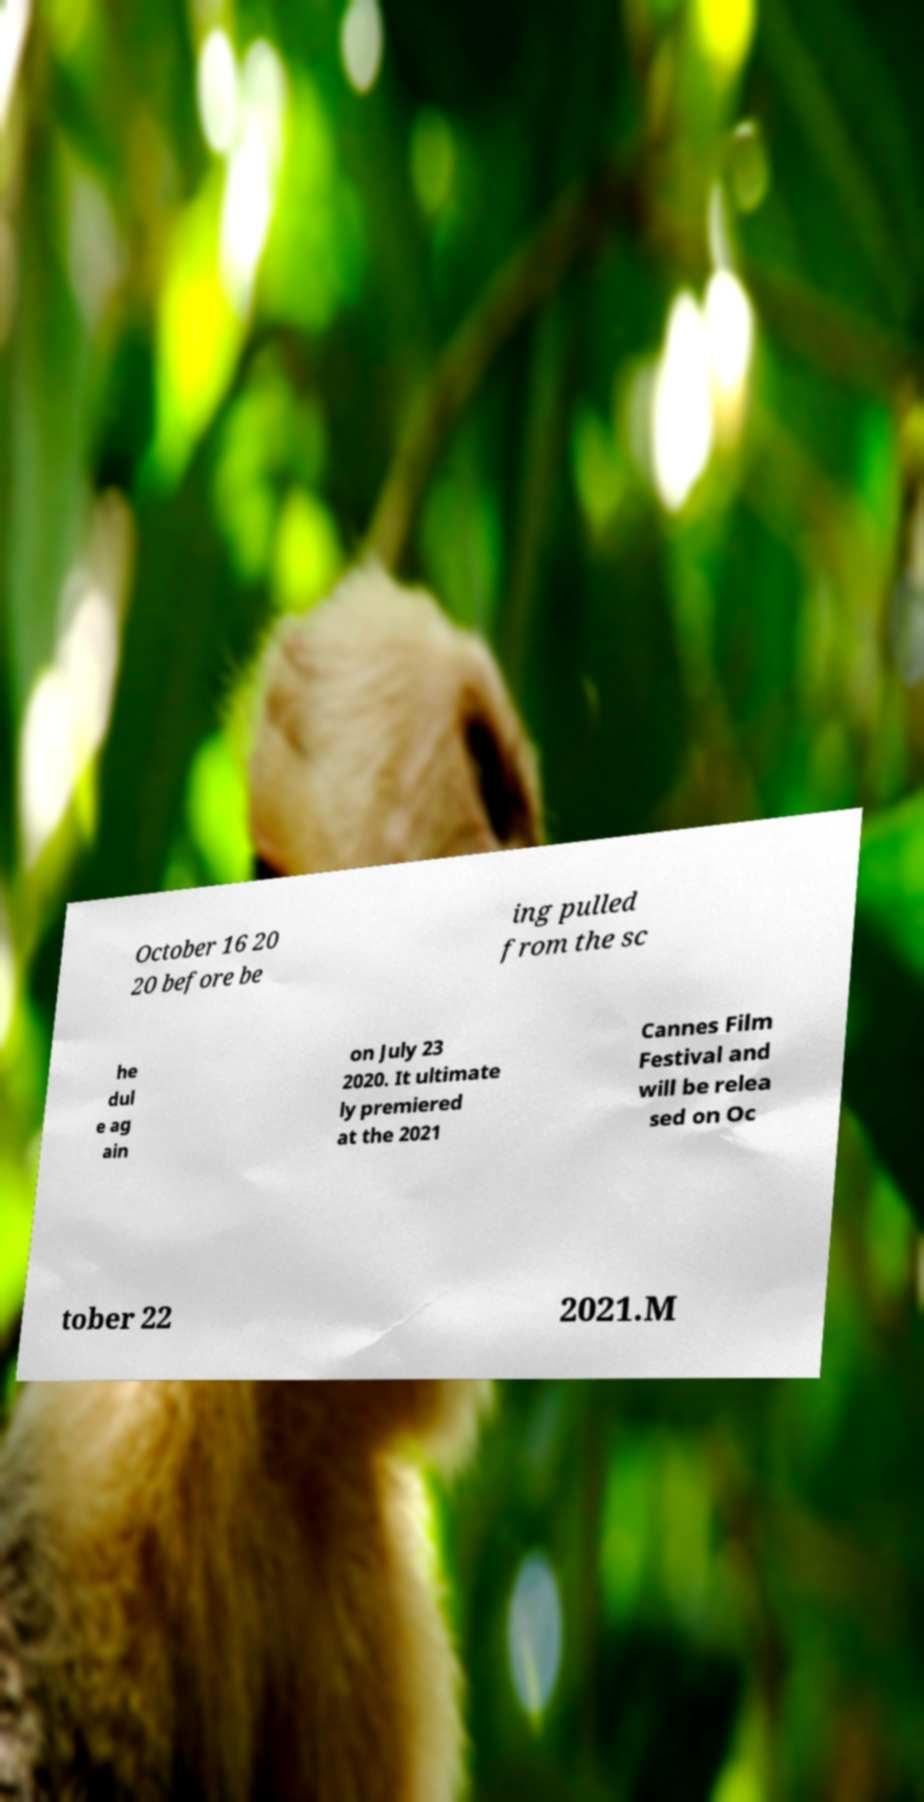Can you accurately transcribe the text from the provided image for me? October 16 20 20 before be ing pulled from the sc he dul e ag ain on July 23 2020. It ultimate ly premiered at the 2021 Cannes Film Festival and will be relea sed on Oc tober 22 2021.M 